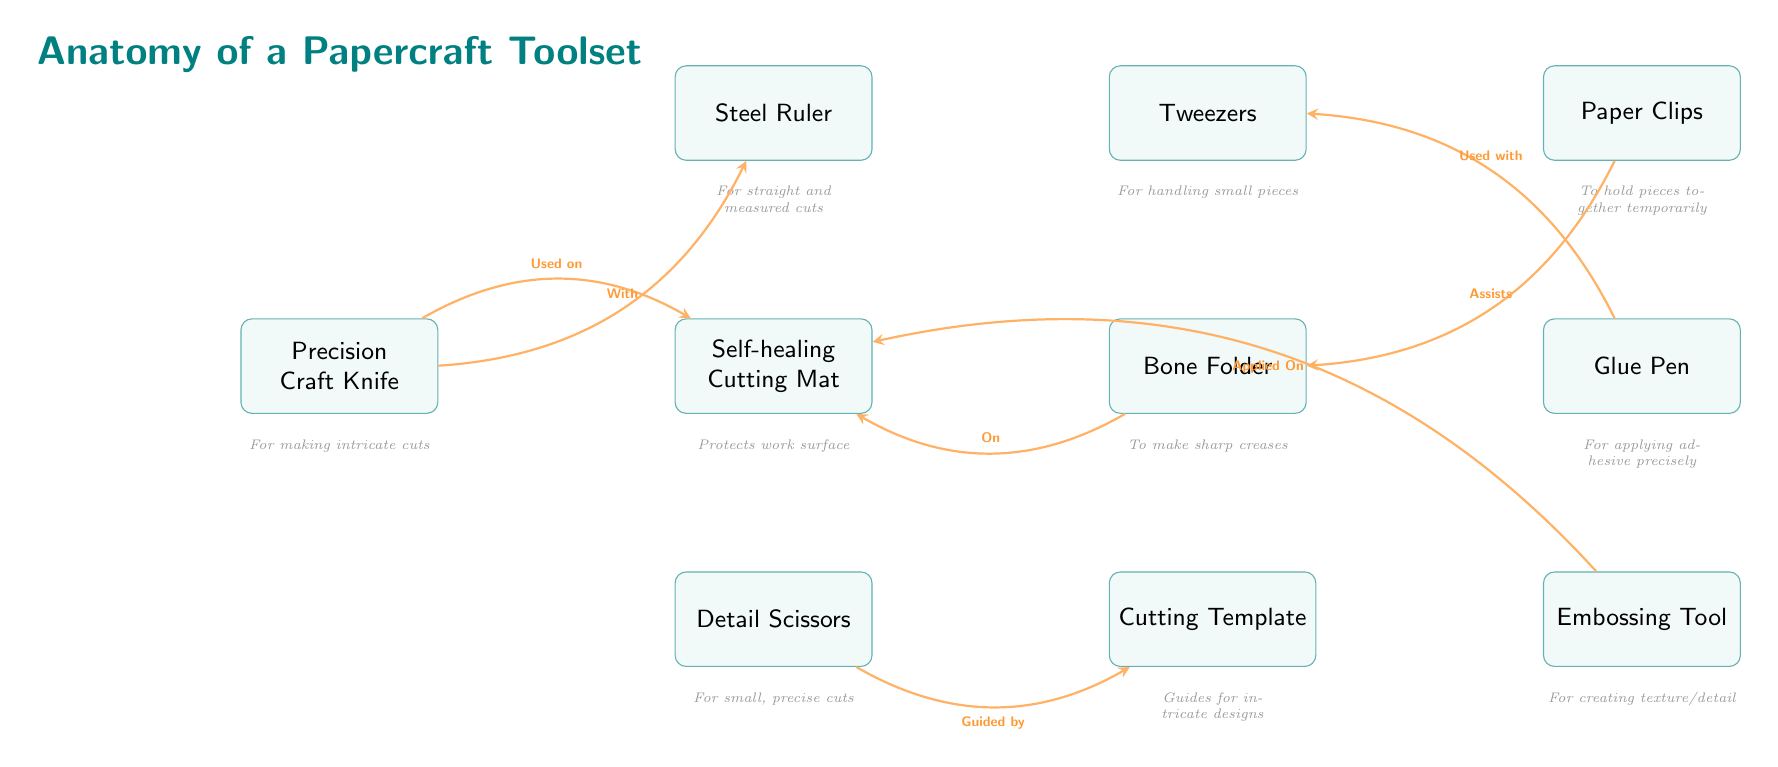What is the tool used for making intricate cuts? The diagram shows that the tool specifically designated for intricate cuts is the "Precision Craft Knife." It is labeled directly above the corresponding description that mentions its purpose.
Answer: Precision Craft Knife How many tools are listed in the diagram? By counting the tool nodes explicitly represented in the diagram, there are a total of 10 tools, each depicted in their respective rectangular nodes.
Answer: 10 What is the purpose of the Self-healing Cutting Mat? The description below the Self-healing Cutting Mat states "Protects work surface," indicating its primary purpose within the papercraft toolset.
Answer: Protects work surface Which tool is used in conjunction with the Tweezers? The diagram indicates that the "Glue Pen" is used with the Tweezers, as shown by the arrow labeled "Used with" that connects these two nodes.
Answer: Glue Pen What two tools are used on the Cutting Mat? The diagram shows that both the "Precision Craft Knife" and the "Embossing Tool" are used on the Cutting Mat, as indicated by the arrows pointing towards the mat from these tools.
Answer: Precision Craft Knife, Embossing Tool Which tool is used for small, precise cuts? Referring to the diagram, the "Detail Scissors" is specifically identified for making small, precise cuts, as mentioned directly in its description below the tool.
Answer: Detail Scissors What assists the Bone Folder? The diagram features an arrow that points from the "Paper Clips" to the "Bone Folder" with the label "Assists," indicating that the Paper Clips assist the Bone Folder in its use.
Answer: Paper Clips What is the relationship between the Template and the Detail Scissors? The diagram describes that the "Cutting Template" is "Guided by" the "Detail Scissors," indicating that users would often use the template as a guide when making cuts with the scissors.
Answer: Guided by What does the Bone Folder help create? The description below the Bone Folder indicates that it is used "To make sharp creases," thus outlining its functional role in the papercrafting process.
Answer: Sharp creases 